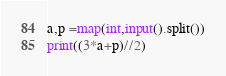Convert code to text. <code><loc_0><loc_0><loc_500><loc_500><_Python_>a,p =map(int,input().split())
print((3*a+p)//2)</code> 